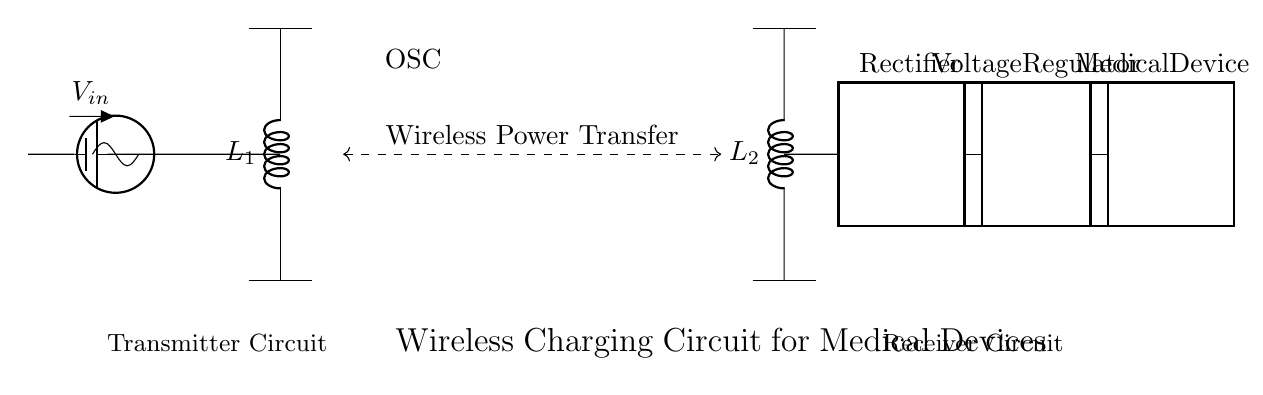What is the input voltage for the circuit? The input voltage is indicated as V-in at the power source, which connects to the oscillator.
Answer: V-in What type of oscillator is used in this circuit? The diagram shows that the oscillator is a basic oscillatory component with no specific type indicated, but it is labeled as OSC in the diagram.
Answer: OSC What does the dashed line represent in this circuit? The dashed line indicates wireless power transfer between the transmitter coil and the receiver coil, showing the mechanism of energy transfer without physical connections.
Answer: Wireless Power Transfer How many main components are there in the transmitter circuit? Looking at the diagram, the transmitter circuit includes a power source (battery), an oscillator, and a transmitter coil, totaling three main components.
Answer: Three What is the function of the rectifier in the circuit? The rectifier is responsible for converting the alternating current (AC) generated in the receiver coil into direct current (DC) suitable for powering the medical device.
Answer: Conversion to DC What is the output of the voltage regulator? The voltage regulator ensures that the output voltage remains stable at a specific level, which will be suitable for the load (medical device). Although a specific value is not indicated, it is a regulated voltage output suitable for medical use.
Answer: Regulated output voltage 